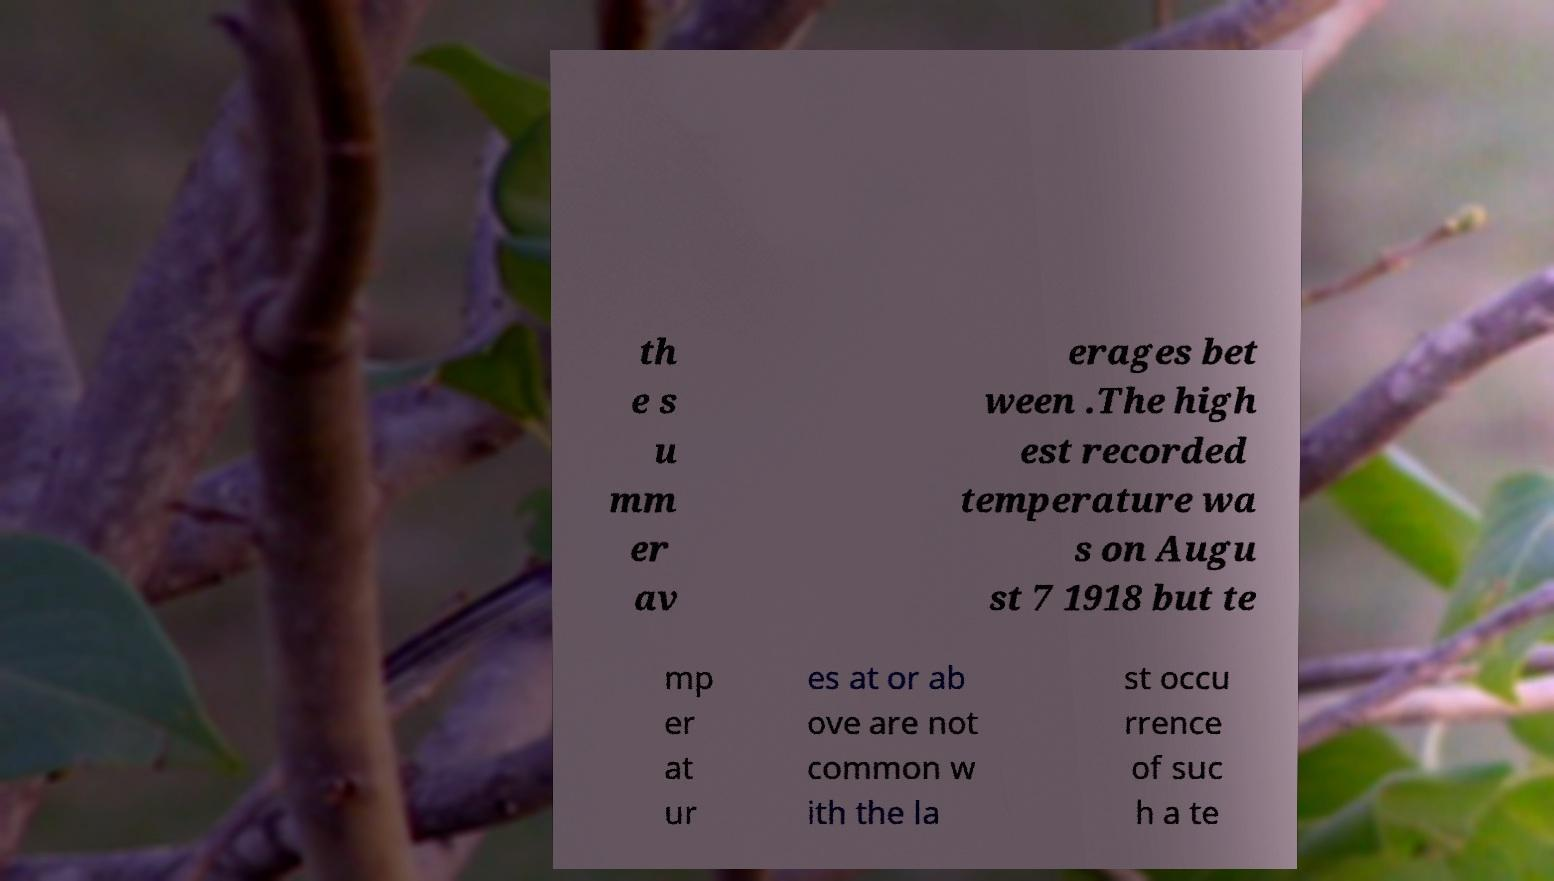Can you read and provide the text displayed in the image?This photo seems to have some interesting text. Can you extract and type it out for me? th e s u mm er av erages bet ween .The high est recorded temperature wa s on Augu st 7 1918 but te mp er at ur es at or ab ove are not common w ith the la st occu rrence of suc h a te 